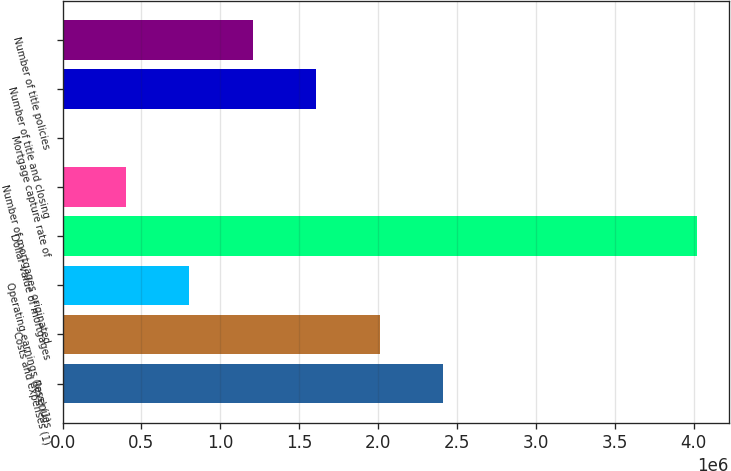<chart> <loc_0><loc_0><loc_500><loc_500><bar_chart><fcel>Revenues<fcel>Costs and expenses (1)<fcel>Operating earnings (loss) (1)<fcel>Dollar value of mortgages<fcel>Number of mortgages originated<fcel>Mortgage capture rate of<fcel>Number of title and closing<fcel>Number of title policies<nl><fcel>2.41203e+06<fcel>2.01004e+06<fcel>804070<fcel>4.02e+06<fcel>402078<fcel>87<fcel>1.60805e+06<fcel>1.20606e+06<nl></chart> 